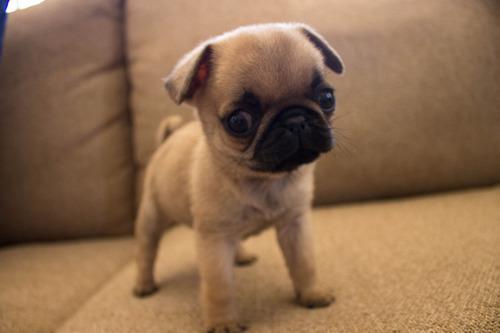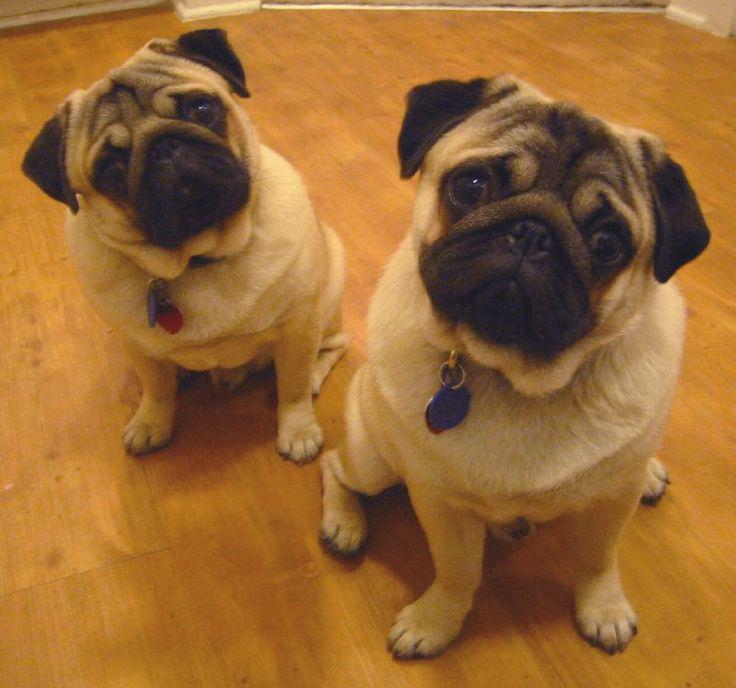The first image is the image on the left, the second image is the image on the right. Examine the images to the left and right. Is the description "There is no more than one dog in the left image." accurate? Answer yes or no. Yes. The first image is the image on the left, the second image is the image on the right. For the images displayed, is the sentence "An image shows two pug dogs side-by-side in a roundish container." factually correct? Answer yes or no. No. 